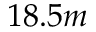Convert formula to latex. <formula><loc_0><loc_0><loc_500><loc_500>1 8 . 5 m</formula> 